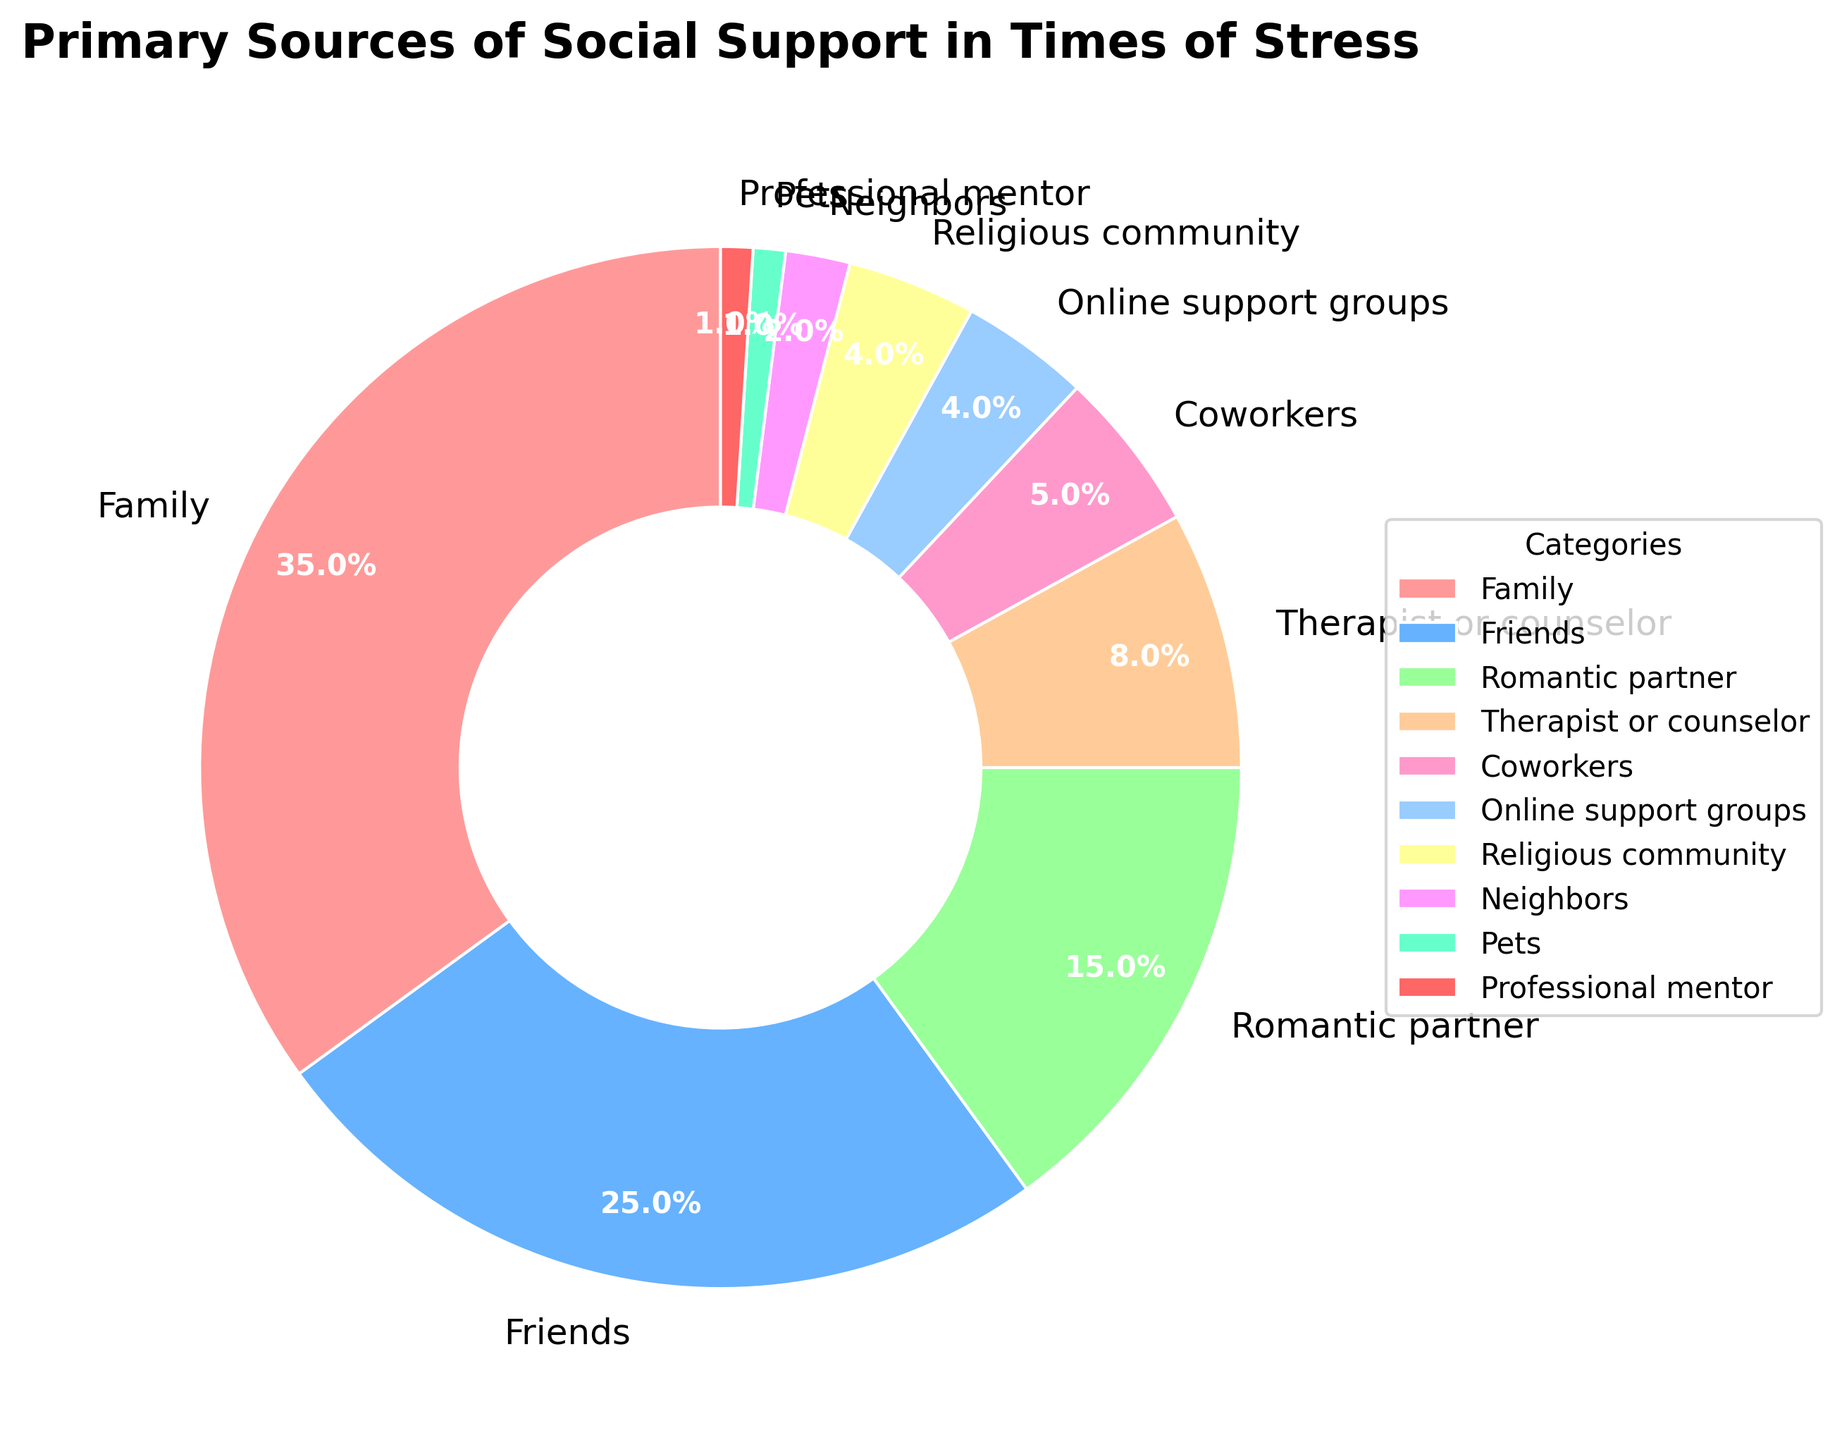What is the category with the highest percentage? By looking at the chart, we can see that the category with the largest section is Family, which represents 35% of the total.
Answer: Family Which two categories combined provide the same percentage as Friends? Adding the percentages of Romantic partner (15%), Therapist or counselor (8%), and Pets (1%) equals 24%, slightly below Friends' 25%. Using Coworkers (5%) instead of Pets gives us a combined percentage of 28%, which is slightly above Friends. The total closest to Friends' percentage is 1% from Pets, 8% from Therapist or counselor, and 15% from Romantic partner.
Answer: Romantic partner and Therapist or counselor Which sources of support have the same percentage of support? By examining the chart, the categories Religious community and Online support groups both have 4% support.
Answer: Religious community and Online support groups How much greater is the percentage for Family compared to Romantic partner? The percentage for Family is 35% and for Romantic partner is 15%. The difference between these two categories is 35% - 15%, which equals 20%.
Answer: 20% What is the total percentage of support provided by less common sources (those below 10%)? Adding the percentages of all categories below 10%: Therapist or counselor (8%), Coworkers (5%), Online support groups (4%), Religious community (4%), Neighbors (2%), Pets (1%), and Professional mentor (1%) gives us a total of 25%.
Answer: 25% Which category is represented by the largest wedge in the pie chart? The category represented by the largest wedge is Family.
Answer: Family Compare the total percentage provided by Friends and Romantic partner to the total percentage provided by Family. Which is greater? Adding the percentages of Friends (25%) and Romantic partner (15%) gives us 40%, which is greater than Family’s 35%.
Answer: Friends and Romantic partner What color represents the Therapist or counselor category? The wedge representing the Therapist or counselor category is light brown in color.
Answer: Light brown Which category has the smallest percentage and what is it? The category with the smallest percentage is Pets, representing 1% of the total.
Answer: Pets (1%) Is the percentage of support from Friends greater or less than the total percentage of Online support groups and Religious community? The percentage of support from Friends is 25%, while the total percentage of Online support groups and Religious community is 4% + 4% = 8%. Hence, Friends have a greater percentage of support.
Answer: Greater 